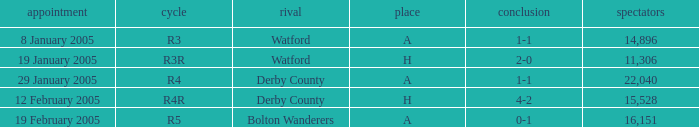What is the round of the game at venue H and opponent of Derby County? R4R. 